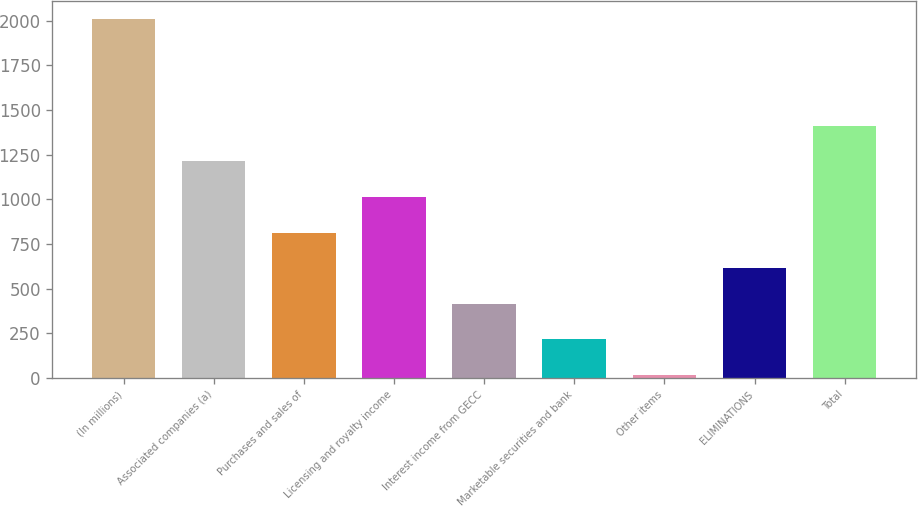Convert chart to OTSL. <chart><loc_0><loc_0><loc_500><loc_500><bar_chart><fcel>(In millions)<fcel>Associated companies (a)<fcel>Purchases and sales of<fcel>Licensing and royalty income<fcel>Interest income from GECC<fcel>Marketable securities and bank<fcel>Other items<fcel>ELIMINATIONS<fcel>Total<nl><fcel>2010<fcel>1212.4<fcel>813.6<fcel>1013<fcel>414.8<fcel>215.4<fcel>16<fcel>614.2<fcel>1411.8<nl></chart> 